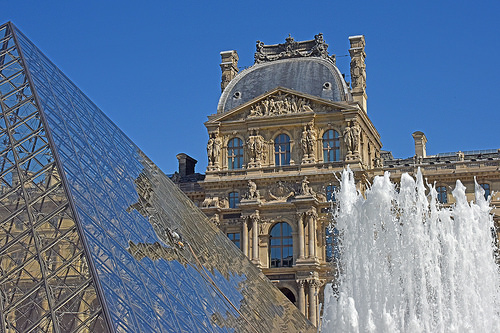<image>
Is the water under the house? No. The water is not positioned under the house. The vertical relationship between these objects is different. Where is the chimney in relation to the fountain? Is it above the fountain? No. The chimney is not positioned above the fountain. The vertical arrangement shows a different relationship. 